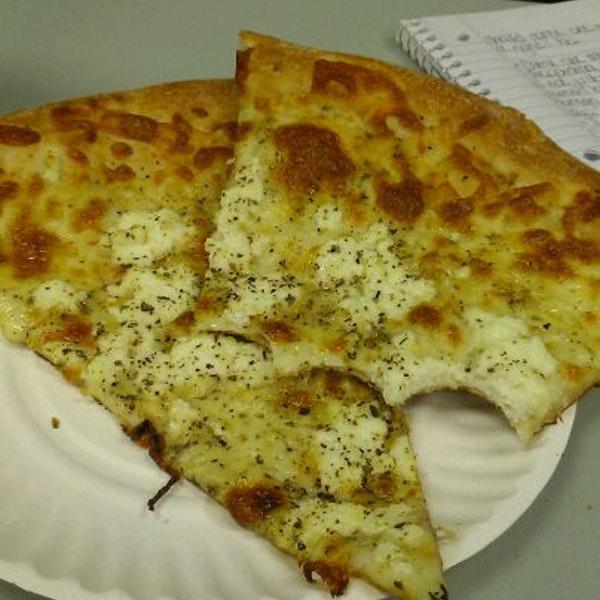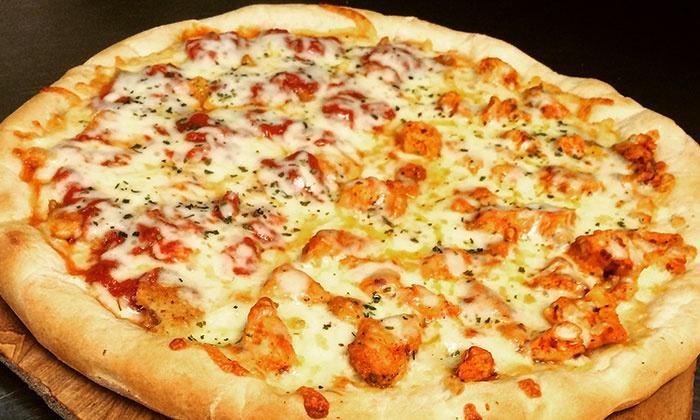The first image is the image on the left, the second image is the image on the right. Examine the images to the left and right. Is the description "One image shows a complete round pizza, and the other image features at least one pizza slice on a white paper plate." accurate? Answer yes or no. Yes. The first image is the image on the left, the second image is the image on the right. Considering the images on both sides, is "There is pizza on a paper plate." valid? Answer yes or no. Yes. 